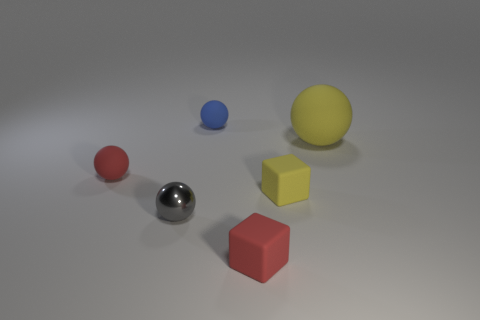Subtract all tiny metallic spheres. How many spheres are left? 3 Subtract all red balls. How many balls are left? 3 Subtract 2 spheres. How many spheres are left? 2 Add 2 tiny matte balls. How many objects exist? 8 Subtract all blocks. How many objects are left? 4 Subtract all purple blocks. Subtract all brown cylinders. How many blocks are left? 2 Subtract all purple metal cubes. Subtract all tiny matte balls. How many objects are left? 4 Add 5 red rubber blocks. How many red rubber blocks are left? 6 Add 4 yellow blocks. How many yellow blocks exist? 5 Subtract 0 purple spheres. How many objects are left? 6 